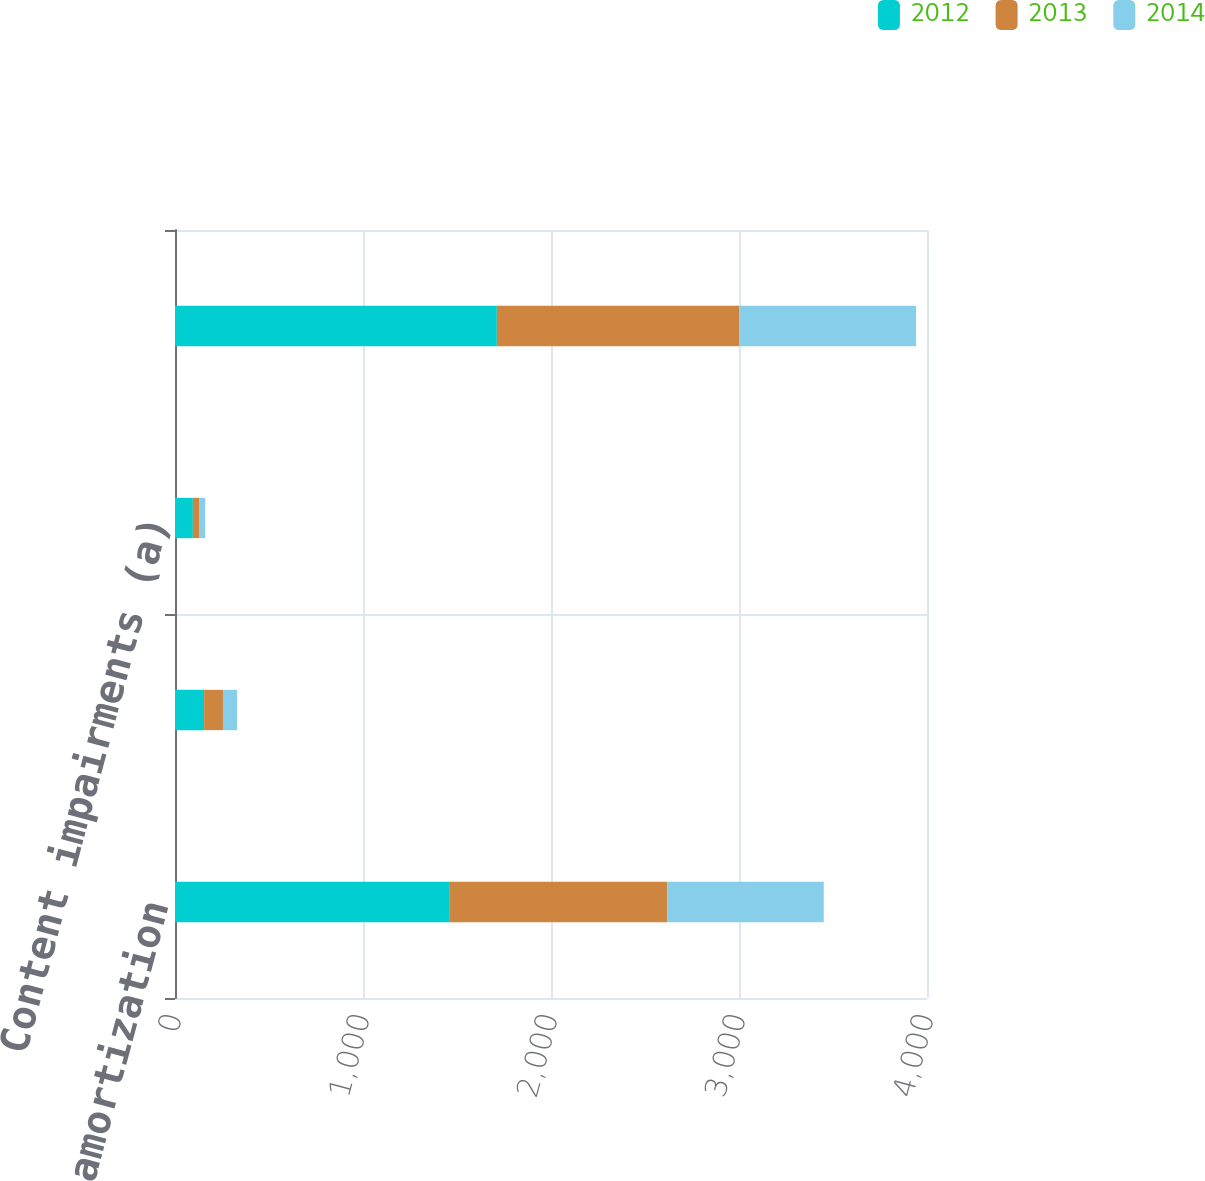Convert chart to OTSL. <chart><loc_0><loc_0><loc_500><loc_500><stacked_bar_chart><ecel><fcel>Content amortization<fcel>Other production charges<fcel>Content impairments (a)<fcel>Total content expense<nl><fcel>2012<fcel>1462<fcel>155<fcel>95<fcel>1712<nl><fcel>2013<fcel>1157<fcel>100<fcel>33<fcel>1290<nl><fcel>2014<fcel>832<fcel>75<fcel>33<fcel>940<nl></chart> 